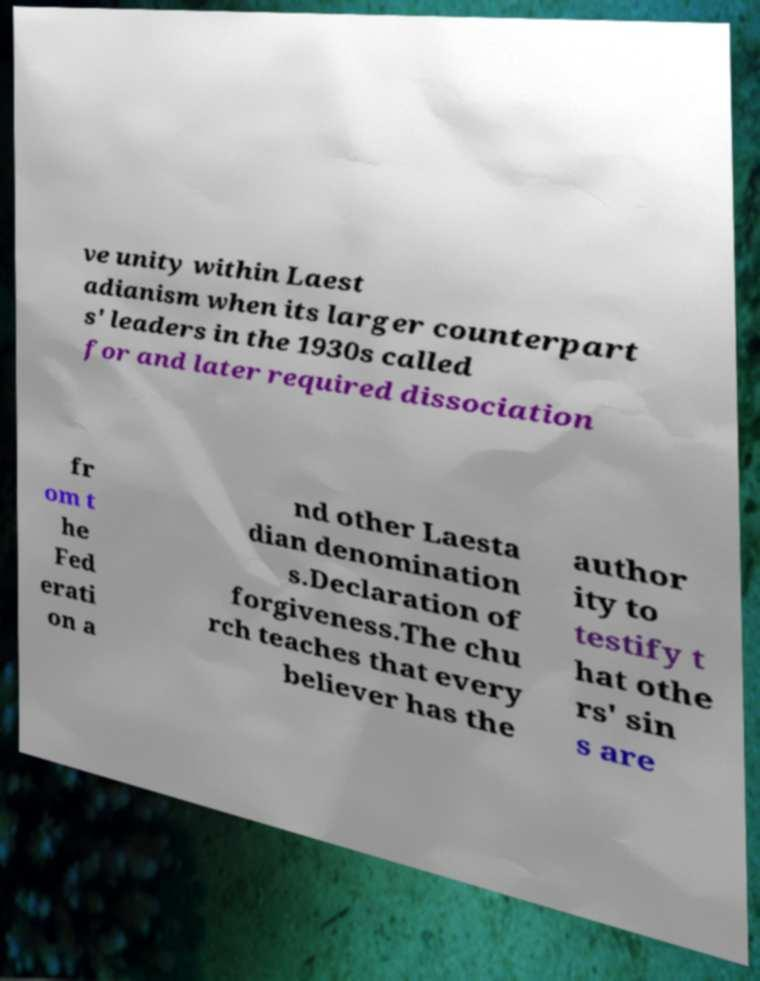There's text embedded in this image that I need extracted. Can you transcribe it verbatim? ve unity within Laest adianism when its larger counterpart s' leaders in the 1930s called for and later required dissociation fr om t he Fed erati on a nd other Laesta dian denomination s.Declaration of forgiveness.The chu rch teaches that every believer has the author ity to testify t hat othe rs' sin s are 